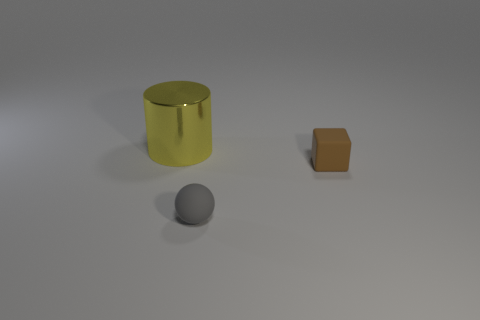Add 2 cubes. How many objects exist? 5 Subtract all balls. How many objects are left? 2 Add 1 big yellow cylinders. How many big yellow cylinders are left? 2 Add 3 blue cylinders. How many blue cylinders exist? 3 Subtract 0 cyan spheres. How many objects are left? 3 Subtract all large gray rubber balls. Subtract all big yellow metal objects. How many objects are left? 2 